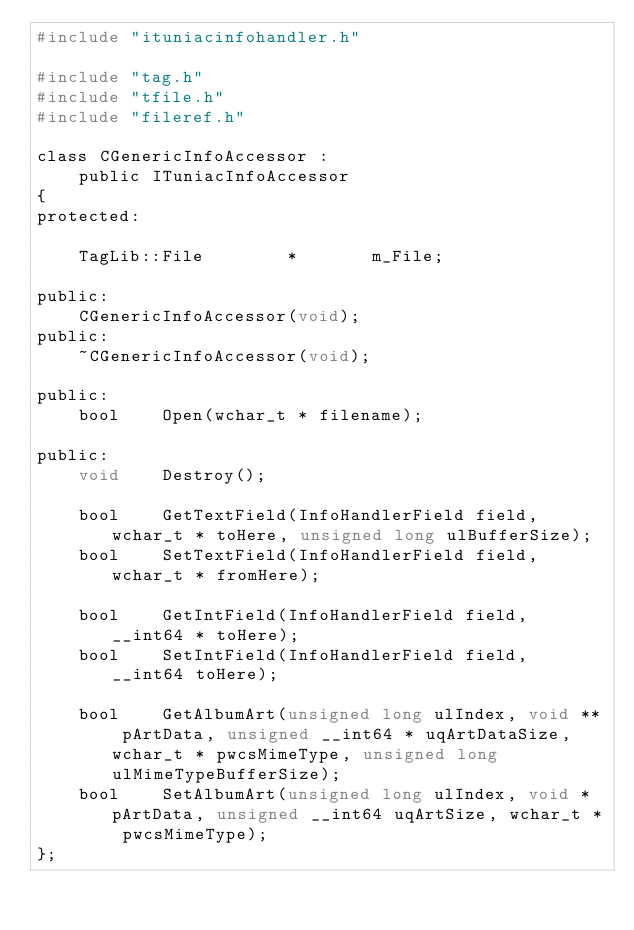<code> <loc_0><loc_0><loc_500><loc_500><_C_>#include "ituniacinfohandler.h"

#include "tag.h"
#include "tfile.h"
#include "fileref.h"

class CGenericInfoAccessor :
	public ITuniacInfoAccessor
{
protected:

	TagLib::File		*		m_File;

public:
	CGenericInfoAccessor(void);
public:
	~CGenericInfoAccessor(void);

public:
	bool	Open(wchar_t * filename);

public:
	void	Destroy();

	bool	GetTextField(InfoHandlerField field, wchar_t * toHere, unsigned long ulBufferSize);
	bool	SetTextField(InfoHandlerField field, wchar_t * fromHere);

	bool	GetIntField(InfoHandlerField field, __int64 * toHere);
	bool	SetIntField(InfoHandlerField field, __int64 toHere);

	bool	GetAlbumArt(unsigned long ulIndex, void ** pArtData, unsigned __int64 * uqArtDataSize, wchar_t * pwcsMimeType, unsigned long ulMimeTypeBufferSize);
	bool	SetAlbumArt(unsigned long ulIndex, void * pArtData, unsigned __int64 uqArtSize, wchar_t * pwcsMimeType);
};
</code> 